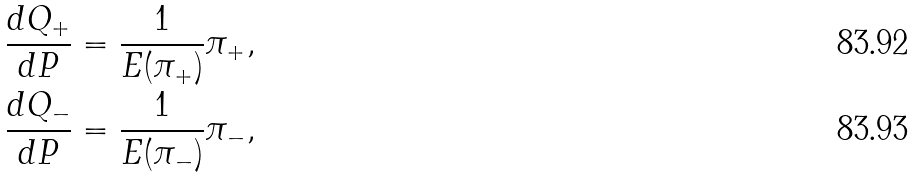<formula> <loc_0><loc_0><loc_500><loc_500>\frac { d Q _ { + } } { d P } & = \frac { 1 } { E ( \pi _ { + } ) } \pi _ { + } , \\ \frac { d Q _ { - } } { d P } & = \frac { 1 } { E ( \pi _ { - } ) } \pi _ { - } ,</formula> 